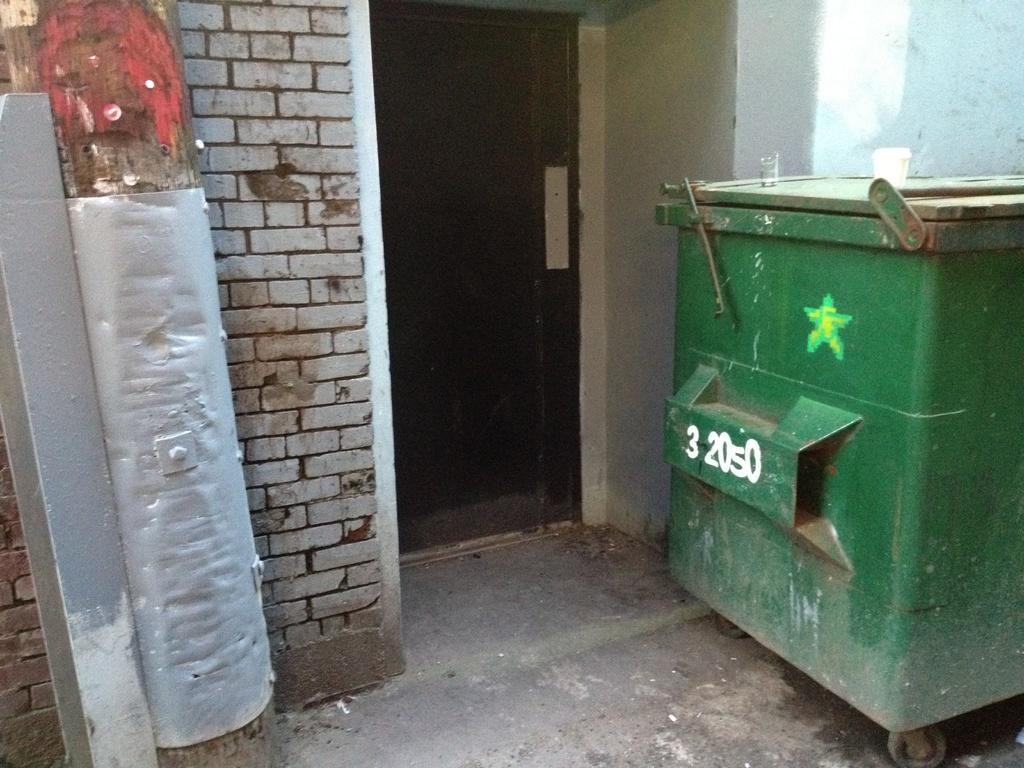What are the numbers in white?
Your answer should be compact. 32050. 